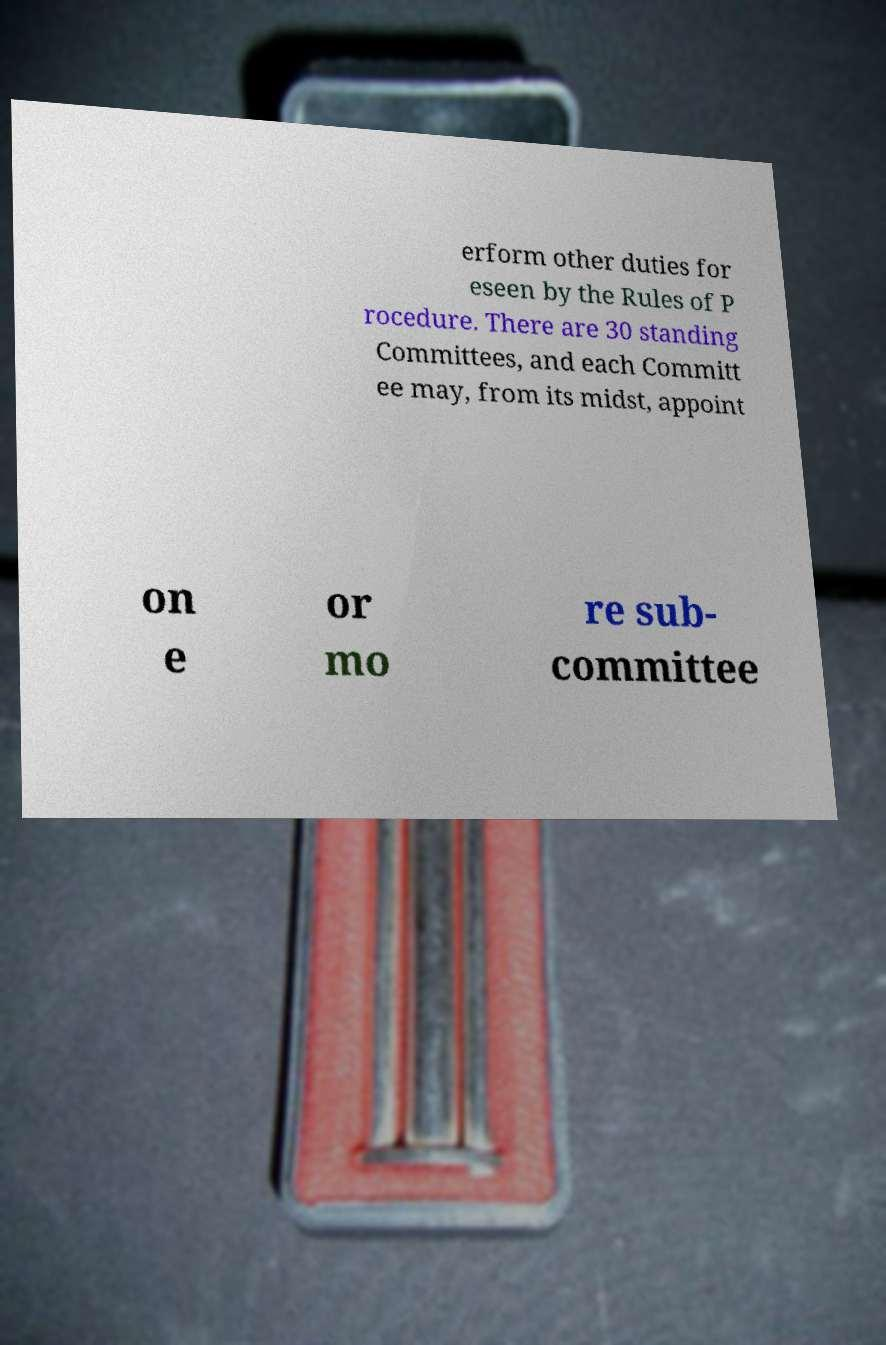Please read and relay the text visible in this image. What does it say? erform other duties for eseen by the Rules of P rocedure. There are 30 standing Committees, and each Committ ee may, from its midst, appoint on e or mo re sub- committee 